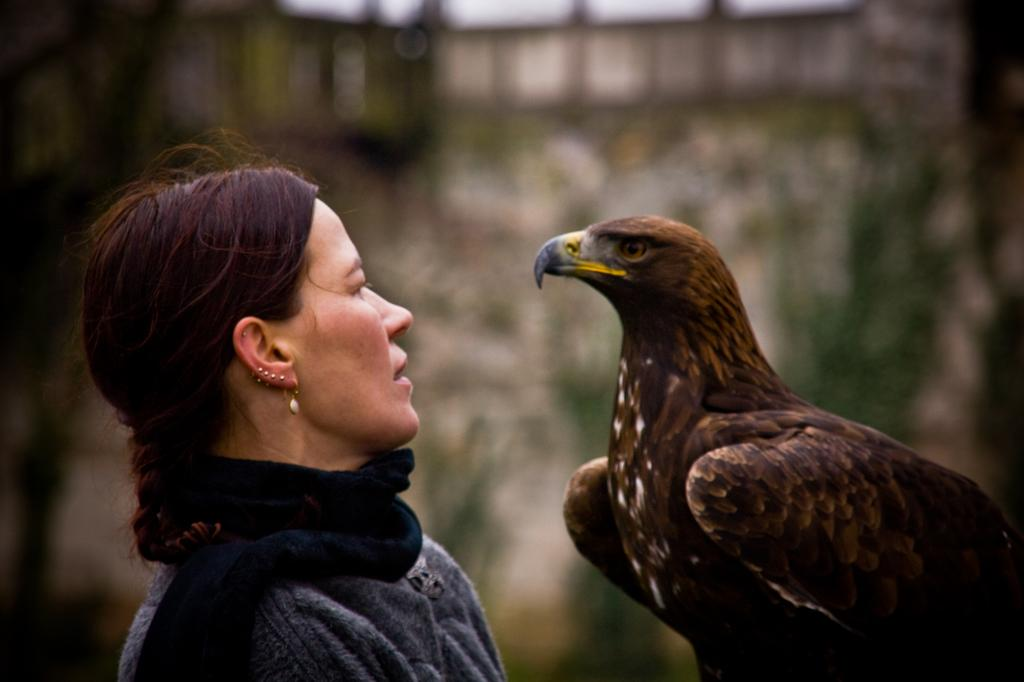Who or what is the main subject in the image? There is a person in the image. What other subject can be seen in the image? There is an eagle in the image. Can you describe the background of the image? The background of the image is blurred. What type of voice does the eagle have in the image? There is no indication of the eagle's voice in the image, as it is a still image and not a video or audio recording. 